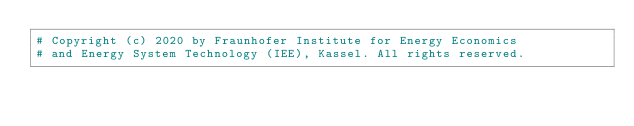Convert code to text. <code><loc_0><loc_0><loc_500><loc_500><_Python_># Copyright (c) 2020 by Fraunhofer Institute for Energy Economics
# and Energy System Technology (IEE), Kassel. All rights reserved.</code> 